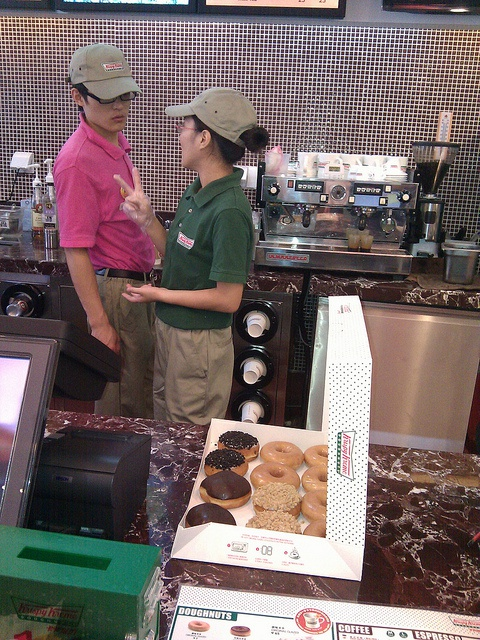Describe the objects in this image and their specific colors. I can see people in black, gray, and darkgray tones, people in black, brown, and maroon tones, refrigerator in black, gray, and tan tones, oven in black, lightgray, and gray tones, and donut in black, maroon, and brown tones in this image. 